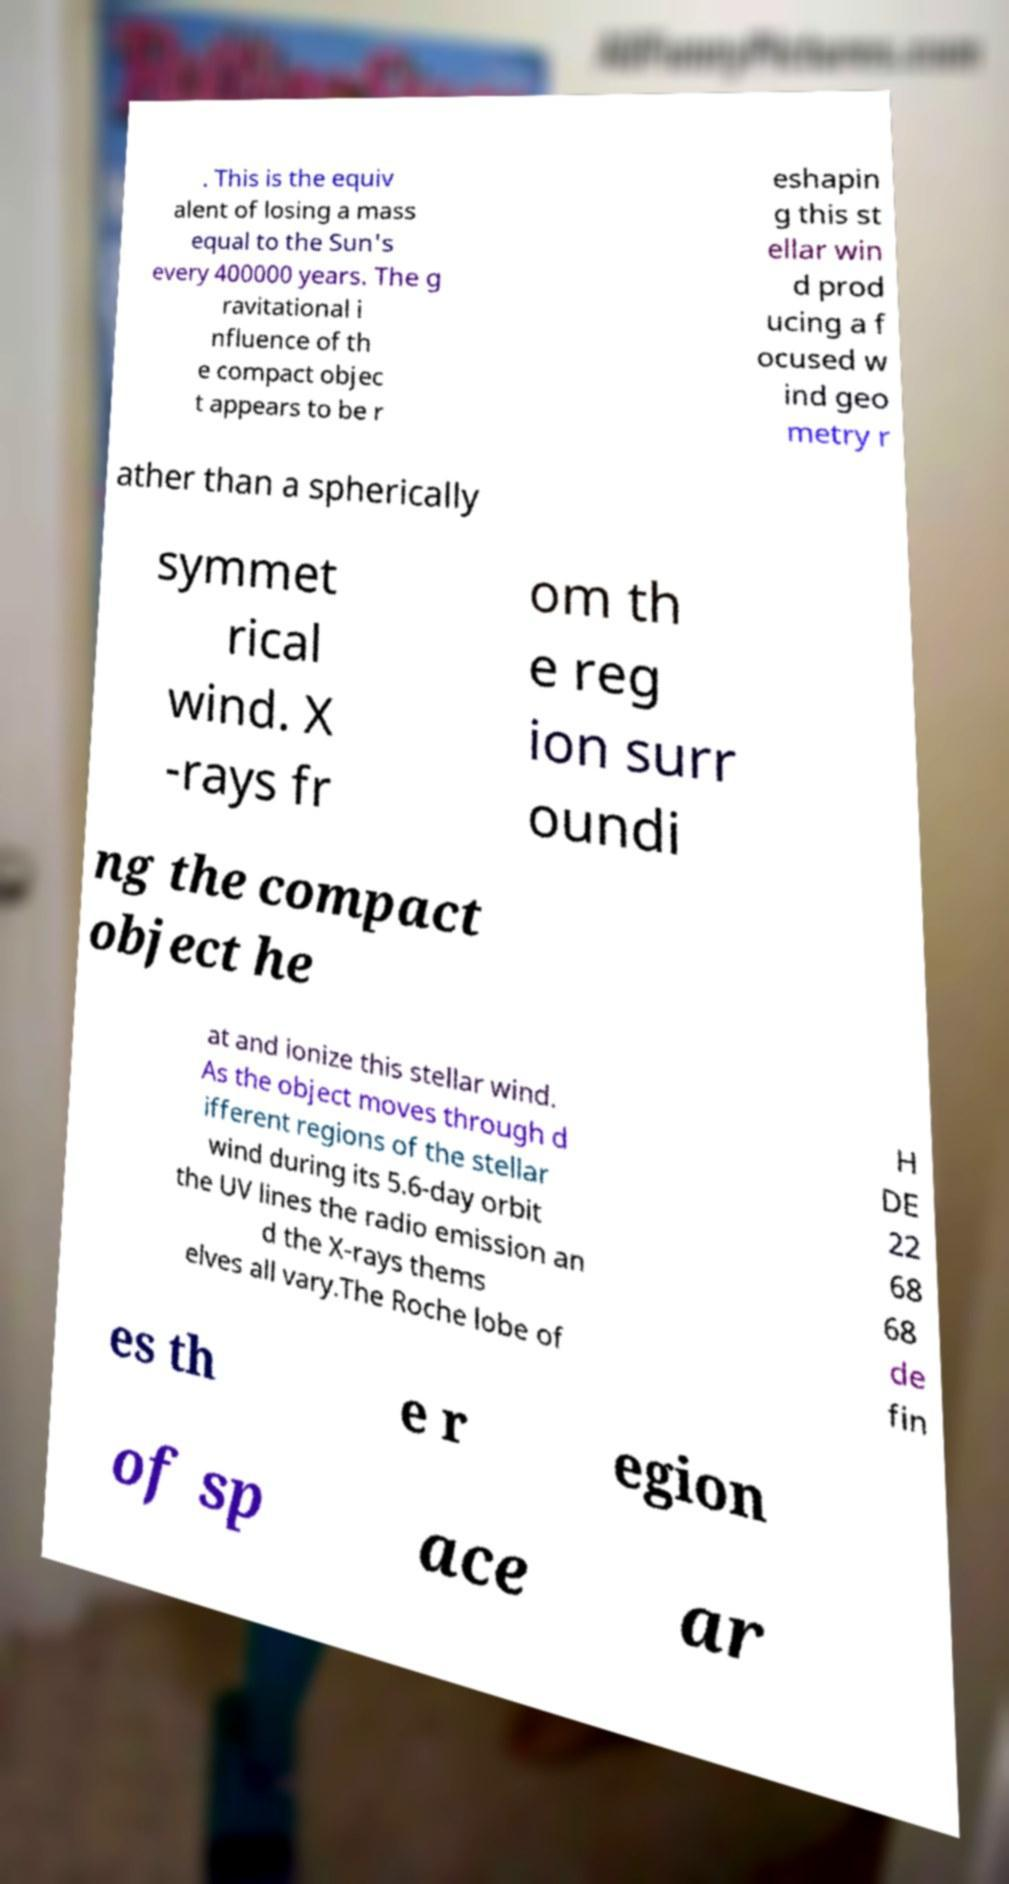Please read and relay the text visible in this image. What does it say? . This is the equiv alent of losing a mass equal to the Sun's every 400000 years. The g ravitational i nfluence of th e compact objec t appears to be r eshapin g this st ellar win d prod ucing a f ocused w ind geo metry r ather than a spherically symmet rical wind. X -rays fr om th e reg ion surr oundi ng the compact object he at and ionize this stellar wind. As the object moves through d ifferent regions of the stellar wind during its 5.6-day orbit the UV lines the radio emission an d the X-rays thems elves all vary.The Roche lobe of H DE 22 68 68 de fin es th e r egion of sp ace ar 